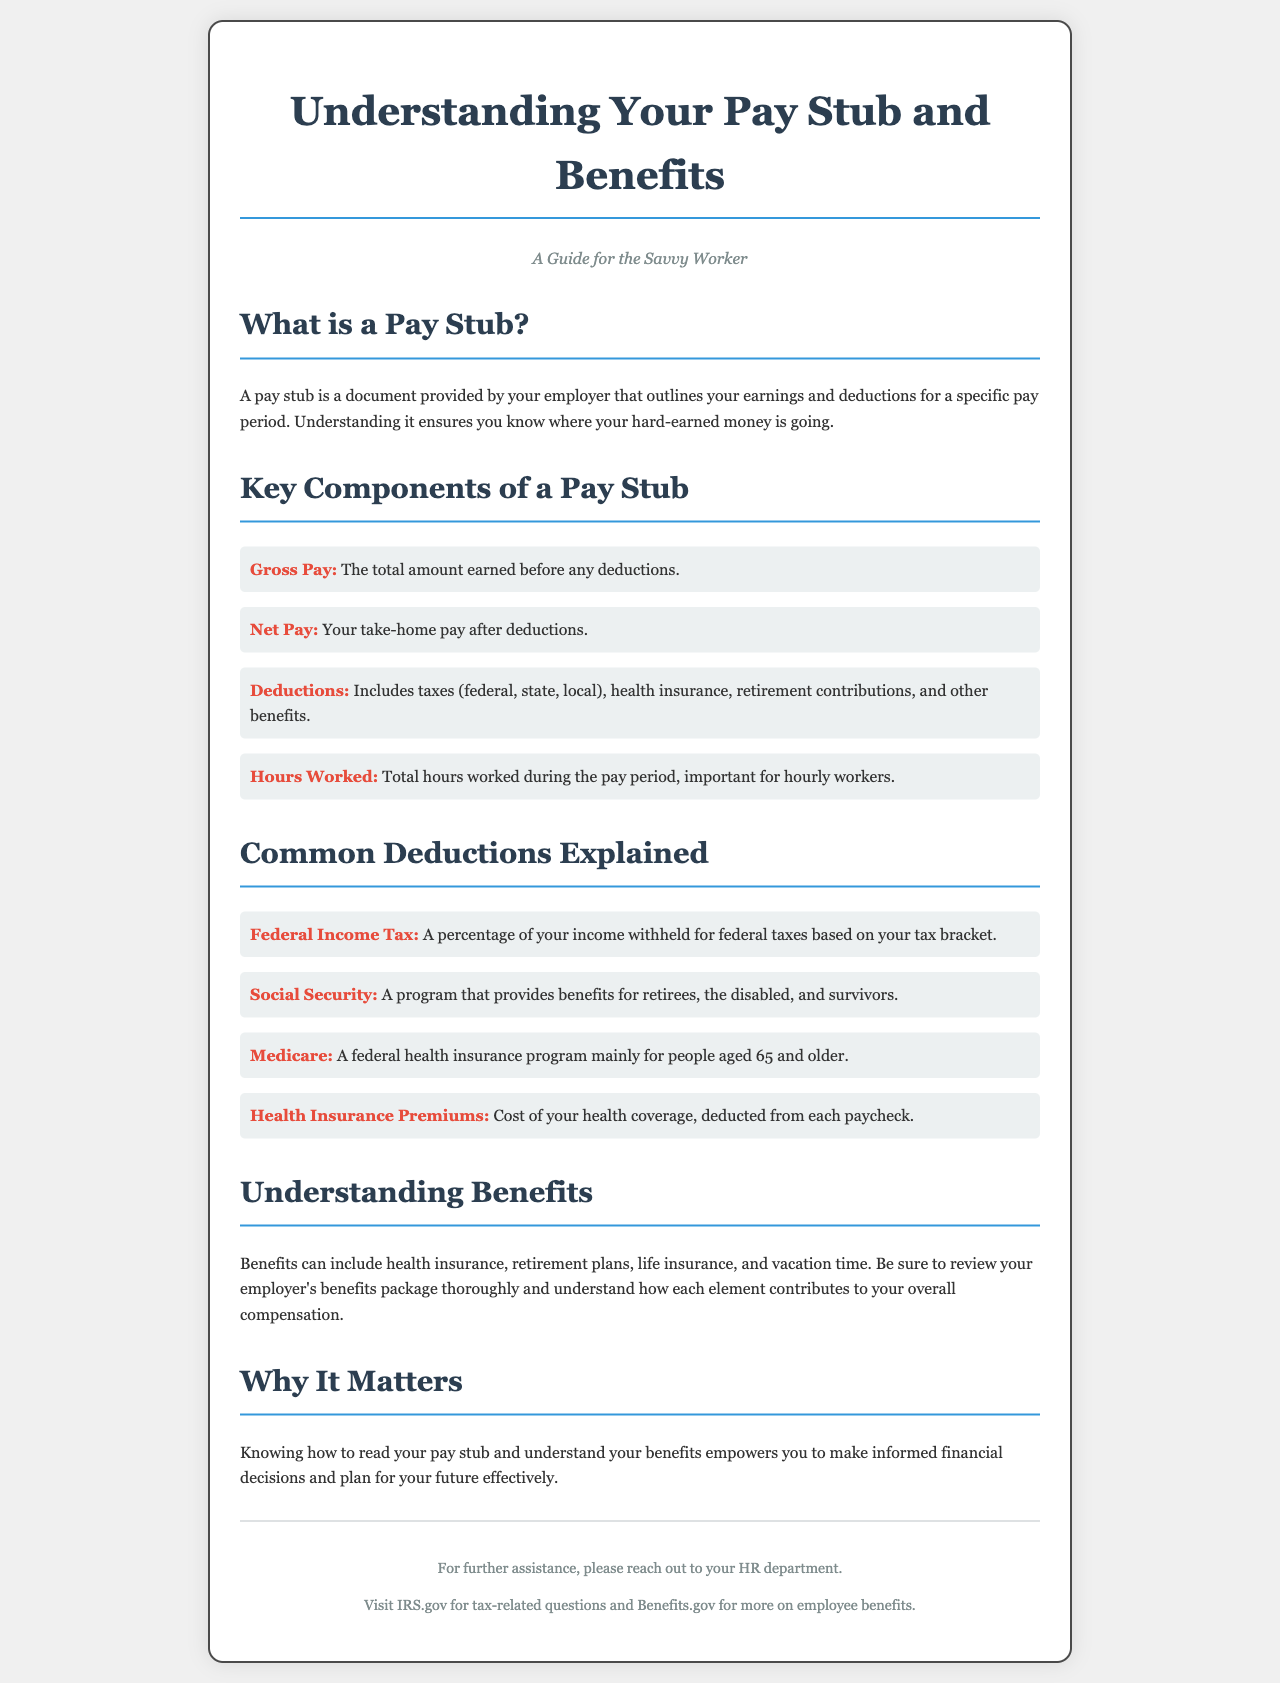What is a pay stub? A pay stub is a document provided by your employer that outlines your earnings and deductions for a specific pay period.
Answer: A document outlining earnings and deductions What does gross pay refer to? Gross pay is defined in the document as the total amount earned before any deductions.
Answer: The total amount earned before deductions What is net pay? Net pay is specifically described as your take-home pay after deductions.
Answer: Your take-home pay after deductions What types of deductions are mentioned? The document lists deductions including taxes (federal, state, local), health insurance, retirement contributions, and other benefits.
Answer: Taxes, health insurance, retirement contributions, other benefits What does Medicare primarily provide? The document explains that Medicare is a federal health insurance program mainly for people aged 65 and older.
Answer: Health insurance for people aged 65 and older Why is understanding your pay stub important? The document states knowing how to read your pay stub empowers you to make informed financial decisions.
Answer: To make informed financial decisions How many key components of a pay stub are listed? There are four key components of a pay stub listed in the document.
Answer: Four Which department should you reach out to for assistance? The document suggests reaching out to your HR department for further assistance.
Answer: HR department 